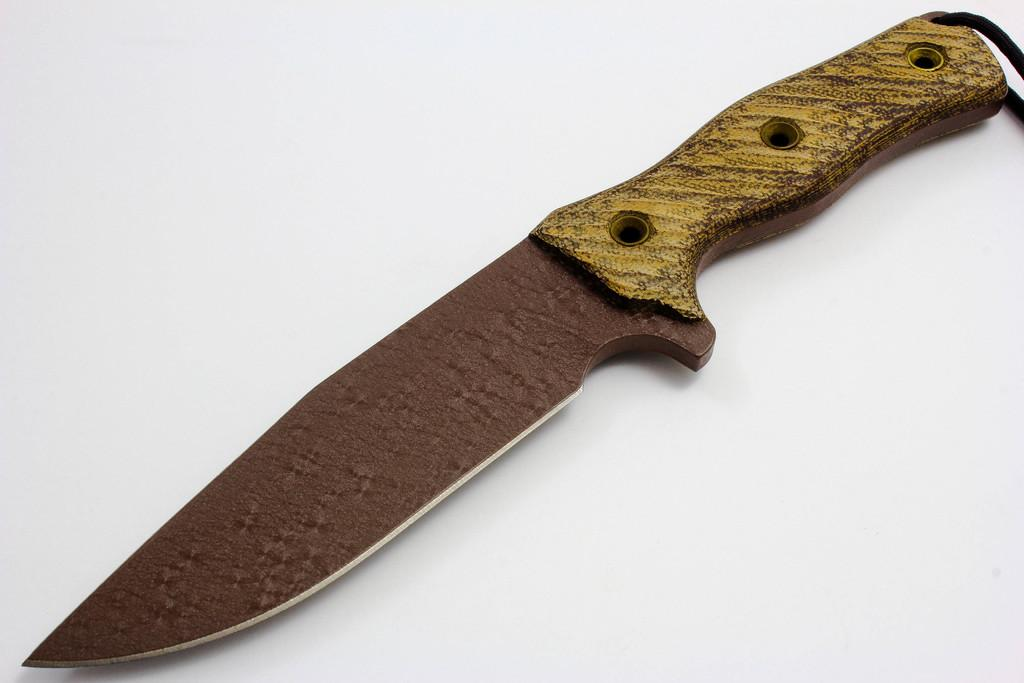What object can be seen in the image? There is a knife in the image. What type of hope can be seen growing on the knife in the image? There is no hope present in the image, as it features only a knife. What is the ear doing in the image? There is no ear present in the image; it only features a knife. 